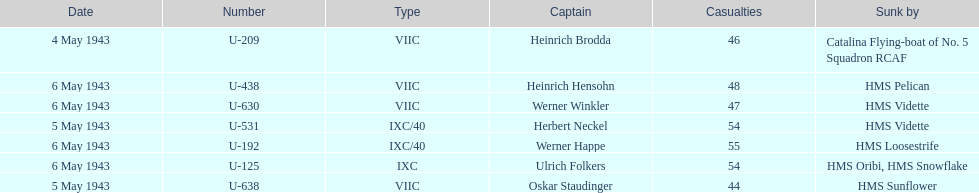Help me parse the entirety of this table. {'header': ['Date', 'Number', 'Type', 'Captain', 'Casualties', 'Sunk by'], 'rows': [['4 May 1943', 'U-209', 'VIIC', 'Heinrich Brodda', '46', 'Catalina Flying-boat of No. 5 Squadron RCAF'], ['6 May 1943', 'U-438', 'VIIC', 'Heinrich Hensohn', '48', 'HMS Pelican'], ['6 May 1943', 'U-630', 'VIIC', 'Werner Winkler', '47', 'HMS Vidette'], ['5 May 1943', 'U-531', 'IXC/40', 'Herbert Neckel', '54', 'HMS Vidette'], ['6 May 1943', 'U-192', 'IXC/40', 'Werner Happe', '55', 'HMS Loosestrife'], ['6 May 1943', 'U-125', 'IXC', 'Ulrich Folkers', '54', 'HMS Oribi, HMS Snowflake'], ['5 May 1943', 'U-638', 'VIIC', 'Oskar Staudinger', '44', 'HMS Sunflower']]} How many captains are listed? 7. 